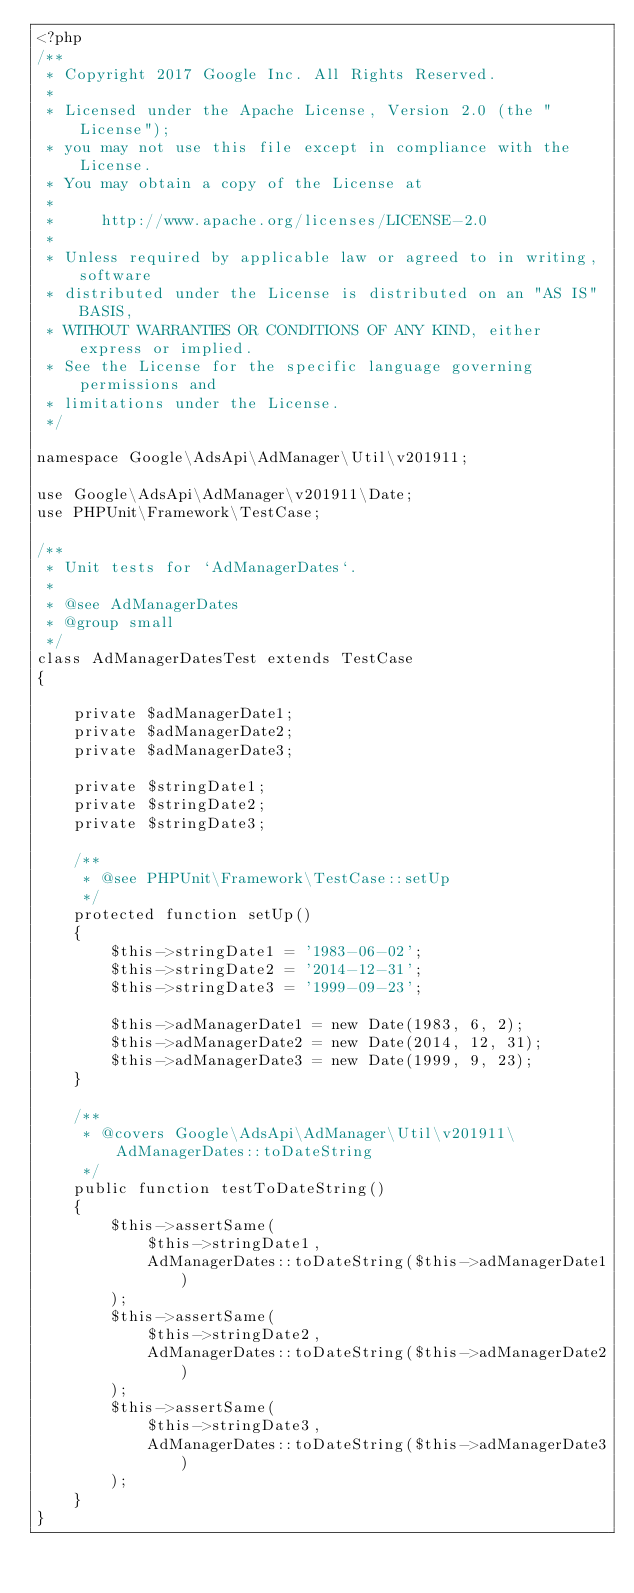<code> <loc_0><loc_0><loc_500><loc_500><_PHP_><?php
/**
 * Copyright 2017 Google Inc. All Rights Reserved.
 *
 * Licensed under the Apache License, Version 2.0 (the "License");
 * you may not use this file except in compliance with the License.
 * You may obtain a copy of the License at
 *
 *     http://www.apache.org/licenses/LICENSE-2.0
 *
 * Unless required by applicable law or agreed to in writing, software
 * distributed under the License is distributed on an "AS IS" BASIS,
 * WITHOUT WARRANTIES OR CONDITIONS OF ANY KIND, either express or implied.
 * See the License for the specific language governing permissions and
 * limitations under the License.
 */

namespace Google\AdsApi\AdManager\Util\v201911;

use Google\AdsApi\AdManager\v201911\Date;
use PHPUnit\Framework\TestCase;

/**
 * Unit tests for `AdManagerDates`.
 *
 * @see AdManagerDates
 * @group small
 */
class AdManagerDatesTest extends TestCase
{

    private $adManagerDate1;
    private $adManagerDate2;
    private $adManagerDate3;

    private $stringDate1;
    private $stringDate2;
    private $stringDate3;

    /**
     * @see PHPUnit\Framework\TestCase::setUp
     */
    protected function setUp()
    {
        $this->stringDate1 = '1983-06-02';
        $this->stringDate2 = '2014-12-31';
        $this->stringDate3 = '1999-09-23';

        $this->adManagerDate1 = new Date(1983, 6, 2);
        $this->adManagerDate2 = new Date(2014, 12, 31);
        $this->adManagerDate3 = new Date(1999, 9, 23);
    }

    /**
     * @covers Google\AdsApi\AdManager\Util\v201911\AdManagerDates::toDateString
     */
    public function testToDateString()
    {
        $this->assertSame(
            $this->stringDate1,
            AdManagerDates::toDateString($this->adManagerDate1)
        );
        $this->assertSame(
            $this->stringDate2,
            AdManagerDates::toDateString($this->adManagerDate2)
        );
        $this->assertSame(
            $this->stringDate3,
            AdManagerDates::toDateString($this->adManagerDate3)
        );
    }
}
</code> 